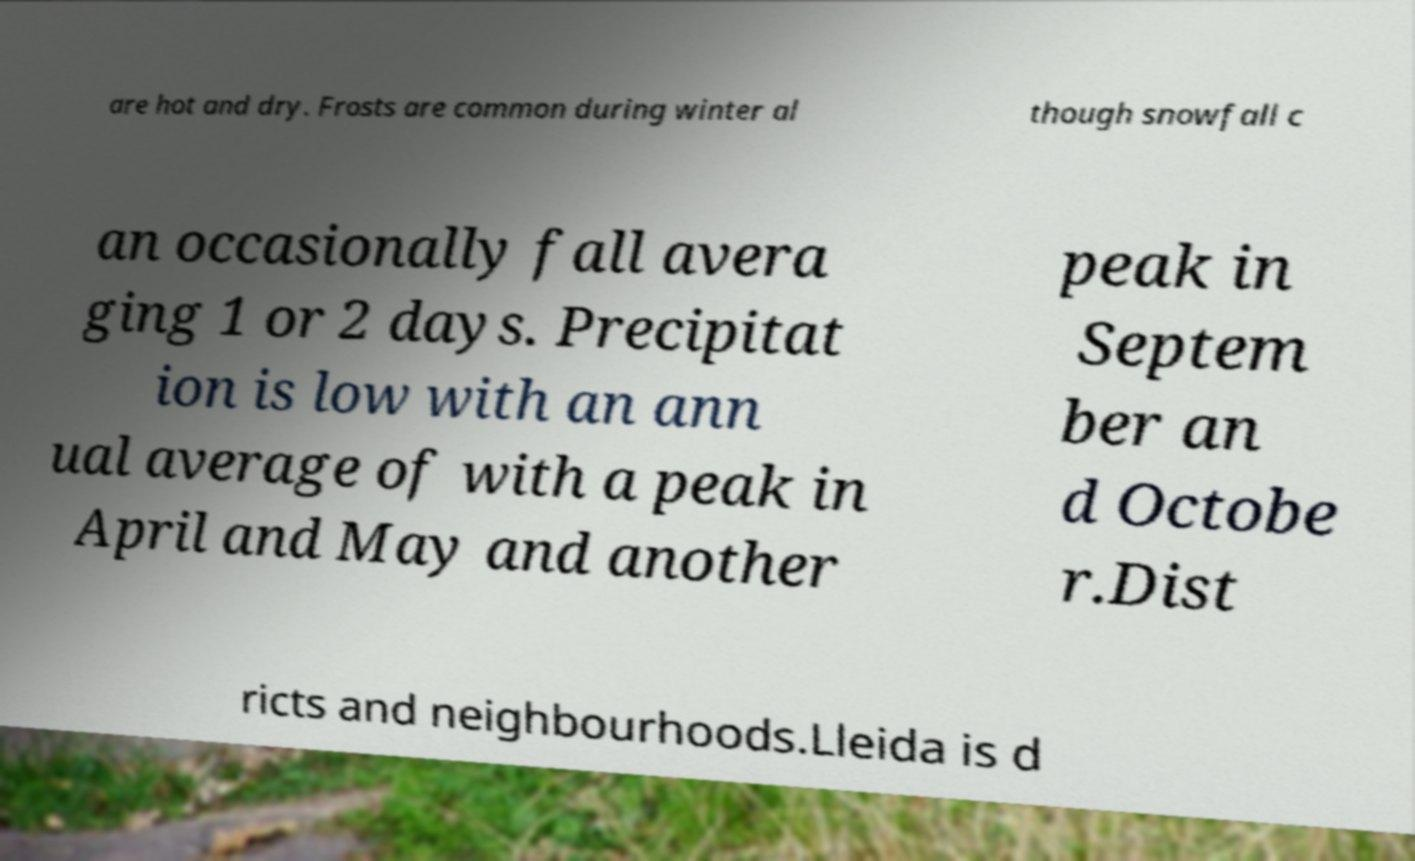Please identify and transcribe the text found in this image. are hot and dry. Frosts are common during winter al though snowfall c an occasionally fall avera ging 1 or 2 days. Precipitat ion is low with an ann ual average of with a peak in April and May and another peak in Septem ber an d Octobe r.Dist ricts and neighbourhoods.Lleida is d 